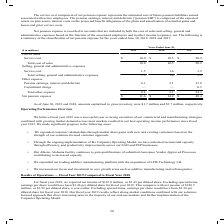According to Carpenter Technology's financial document, What does the service cost component of net pension expense represent? the estimated cost of future pension liabilities earned associated with active employees. The pension earnings, interest and deferrals (“pension EID”) is comprised of the expected return on plan assets, interest costs on the projected benefit obligations of the plans and amortization of actuarial gains and losses and prior service costs.. The document states: "e cost component of net pension expense represents the estimated cost of future pension liabilities earned associated with active employees. The pensi..." Also, How is net pension expense recorded? recorded in accounts that are included in both the cost of sales and selling, general and administrative expenses based on the function of the associated employees and in other income (expense), net.. The document states: "Net pension expense is recorded in accounts that are included in both the cost of sales and selling, general and administrative expenses based on the ..." Also, In which years is the net pension expense recorded? The document contains multiple relevant values: 2019, 2018, 2017. From the document: "($ in millions) 2019 2018 2017 Cost of sales Service cost $ 10.0 $ 10.5 $ 20.2 Total cost of sales 10.0 10.5 20.2 Selling, general ($ in millions) 201..." Additionally, In which year was the total cost of sales the largest? According to the financial document, 2017. The relevant text states: "($ in millions) 2019 2018 2017 Cost of sales Service cost $ 10.0 $ 10.5 $ 20.2 Total cost of sales 10.0 10.5 20.2 Selling, general..." Also, can you calculate: What was the change in Total selling, general and administrative expenses in 2019 from 2018? Based on the calculation: 1.5-1.6, the result is -0.1 (in millions). This is based on the information: "general and administrative expenses Service cost 1.5 1.6 3.9 Total selling, general and administrative expenses 1.5 1.6 3.9 Other expense Pension earnin eral and administrative expenses Service cost 1..." The key data points involved are: 1.5, 1.6. Also, can you calculate: What was the percentage change in Total selling, general and administrative expenses in 2019 from 2018? To answer this question, I need to perform calculations using the financial data. The calculation is: (1.5-1.6)/1.6, which equals -6.25 (percentage). This is based on the information: "general and administrative expenses Service cost 1.5 1.6 3.9 Total selling, general and administrative expenses 1.5 1.6 3.9 Other expense Pension earnin eral and administrative expenses Service cost 1..." The key data points involved are: 1.5, 1.6. 